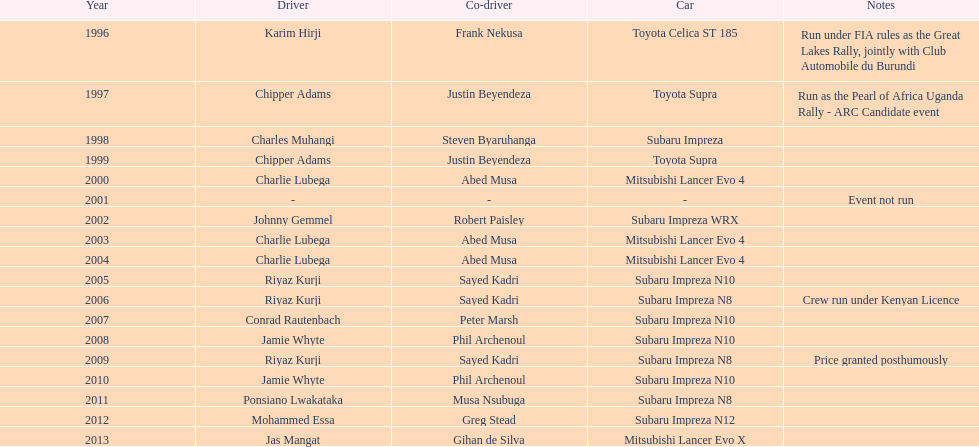How many times has the victorious driver been behind the wheel of a toyota supra? 2. 